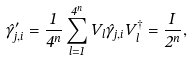Convert formula to latex. <formula><loc_0><loc_0><loc_500><loc_500>\hat { \gamma } ^ { \prime } _ { j , i } = \frac { 1 } { 4 ^ { n } } \sum _ { l = 1 } ^ { 4 ^ { n } } V _ { l } \hat { \gamma } _ { j , i } V _ { l } ^ { \dagger } = \frac { I } { 2 ^ { n } } ,</formula> 